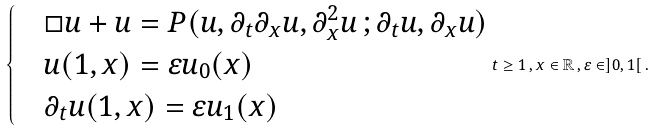Convert formula to latex. <formula><loc_0><loc_0><loc_500><loc_500>\begin{cases} & \Box u + u = P ( u , \partial _ { t } \partial _ { x } u , \partial ^ { 2 } _ { x } u \, ; \partial _ { t } u , \partial _ { x } u ) \\ & u ( 1 , x ) = \varepsilon u _ { 0 } ( x ) \\ & \partial _ { t } u ( 1 , x ) = \varepsilon u _ { 1 } ( x ) \end{cases} t \geq 1 \, , x \in \mathbb { R } \, , \varepsilon \in ] 0 , 1 [ \, .</formula> 